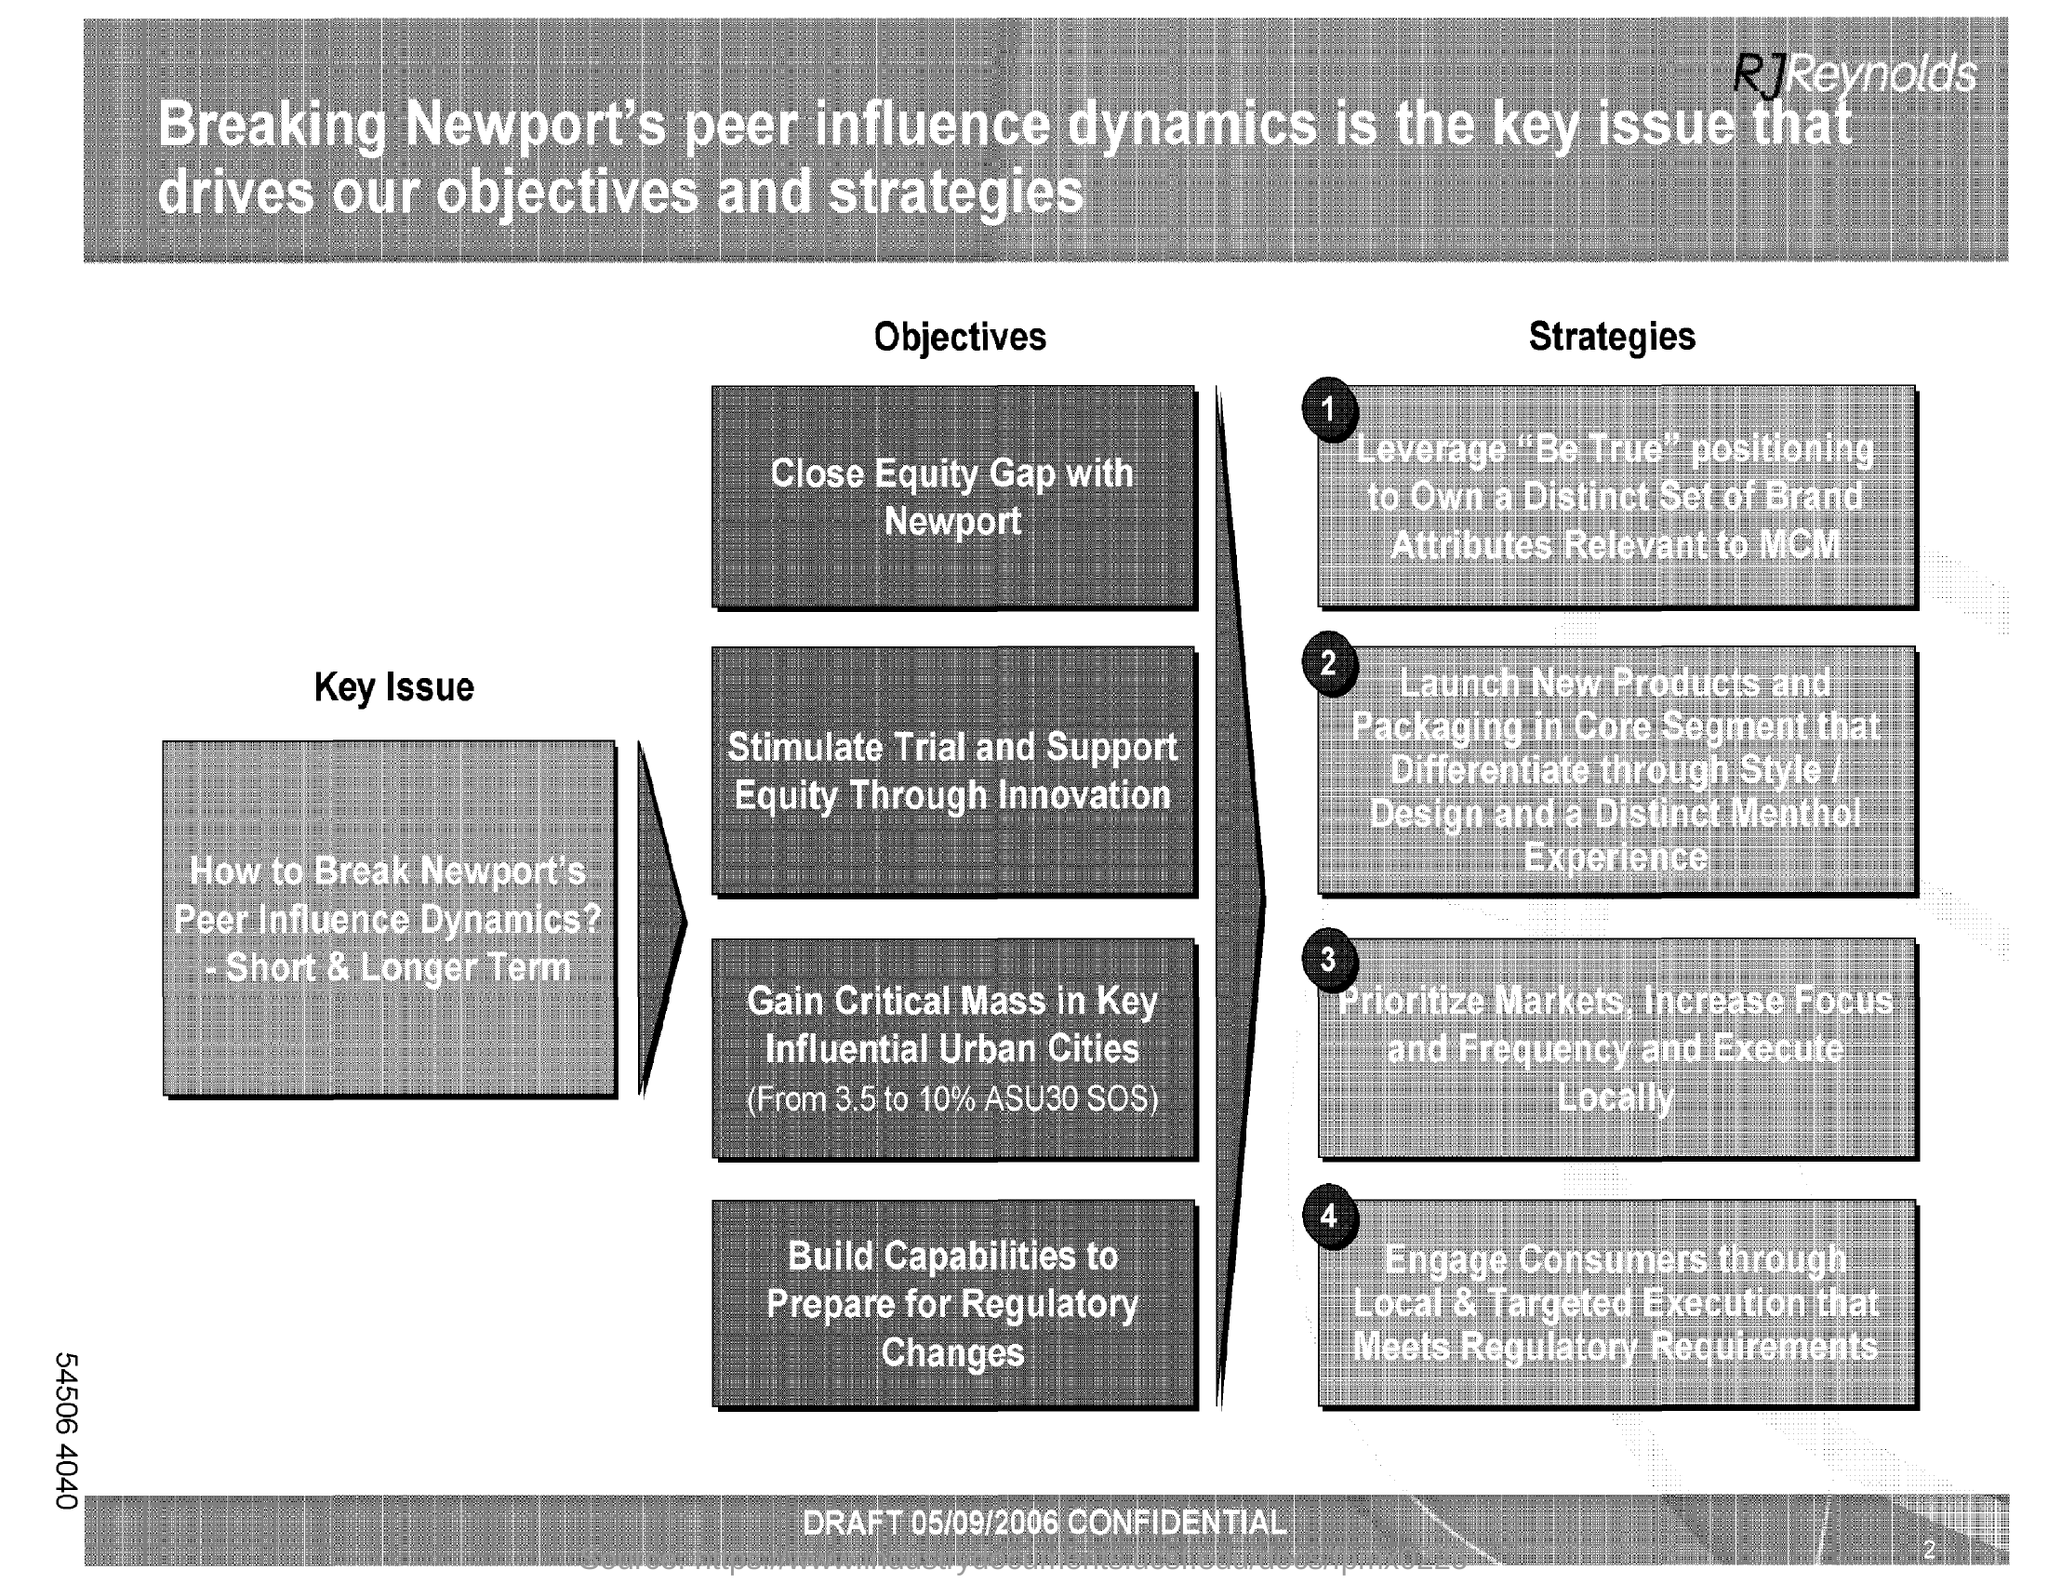What is the key issue?
Offer a very short reply. How to Break Newport's Peer Infuence Dynamics? - Short & Longer Term. 